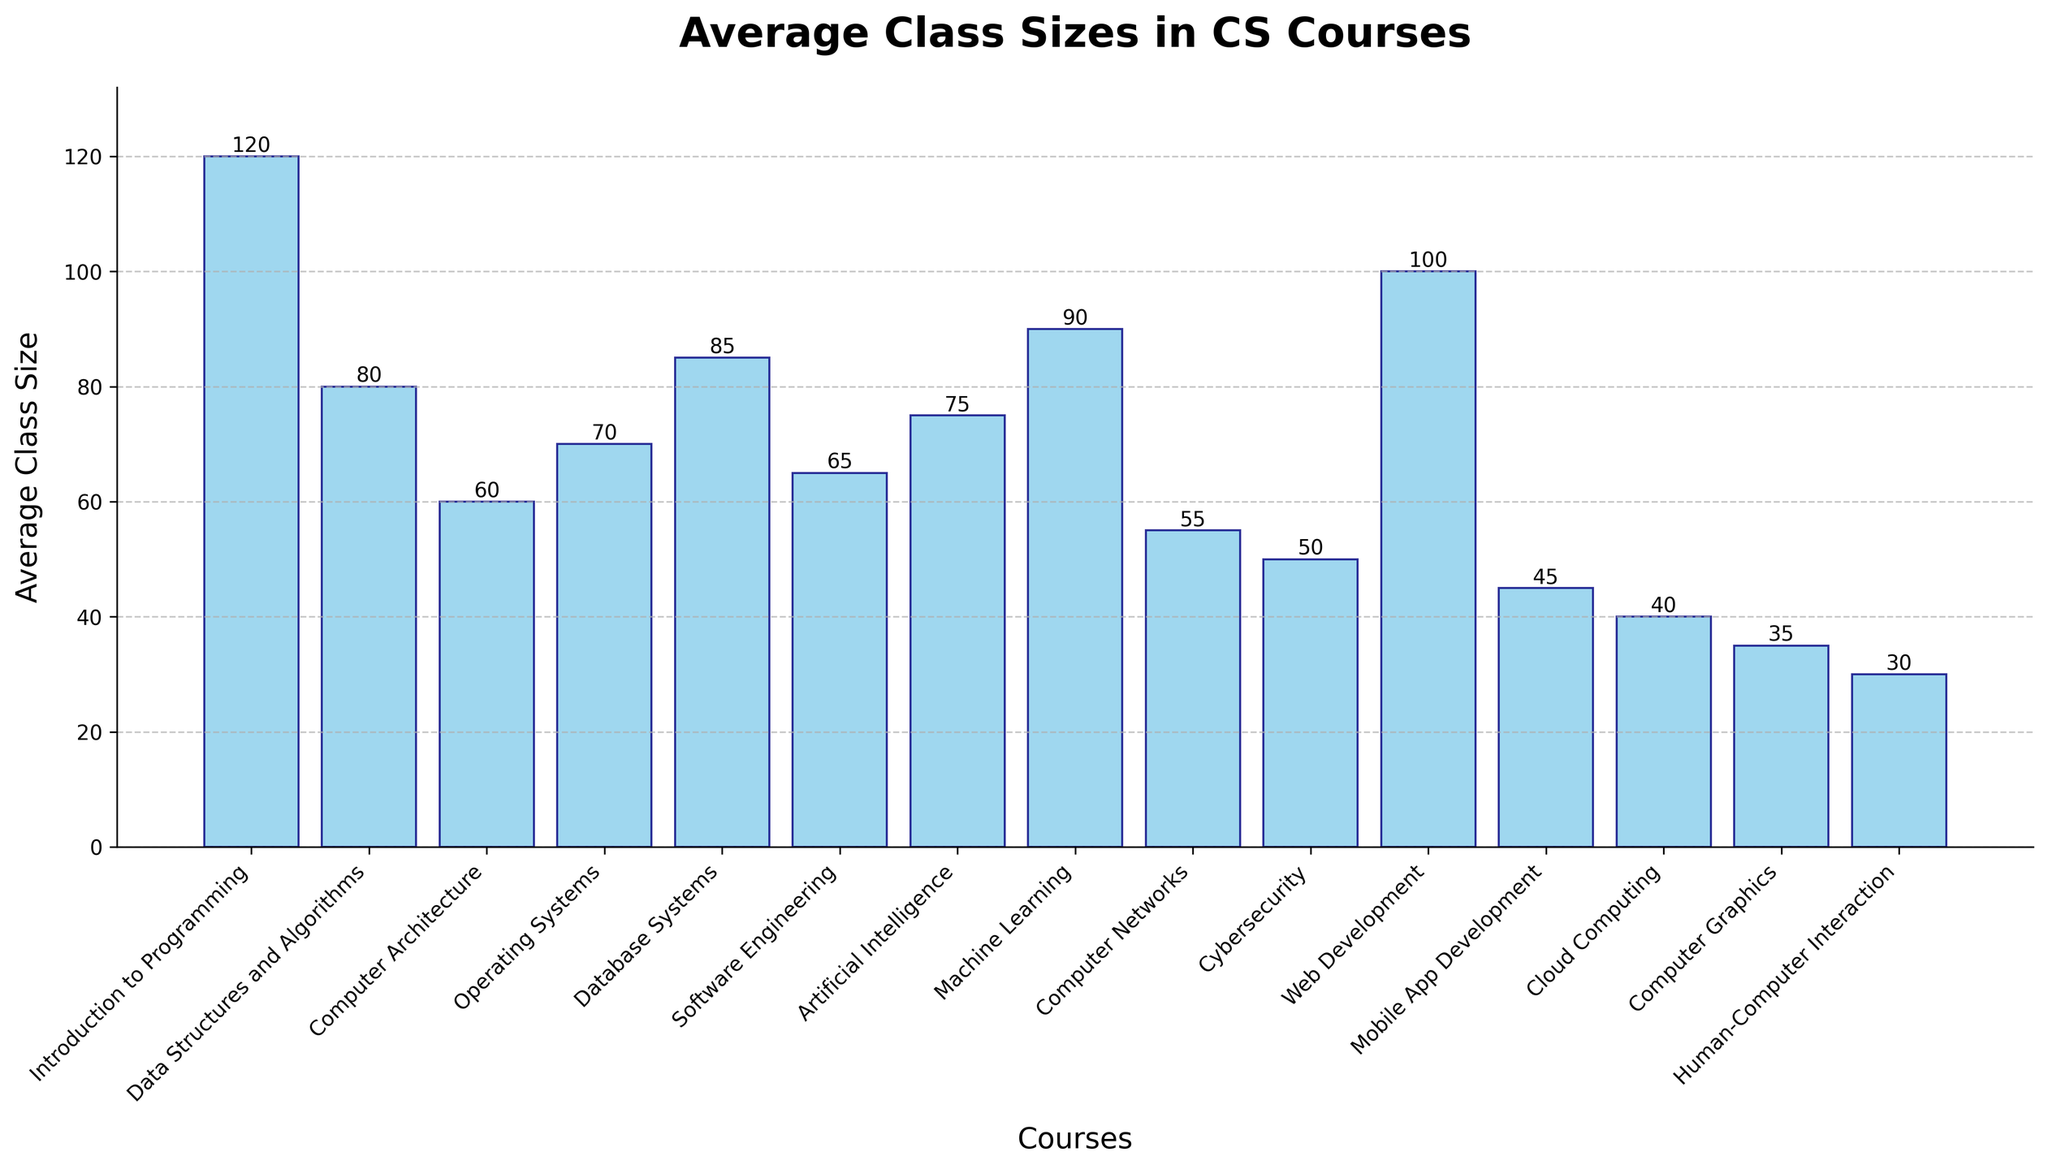Which course has the highest average class size? Look for the bar that reaches the highest point on the y-axis. "Introduction to Programming" has the highest bar.
Answer: Introduction to Programming Which course has the lowest average class size? Look for the bar that is the shortest on the y-axis. "Human-Computer Interaction" has the shortest bar.
Answer: Human-Computer Interaction How much larger is the average class size of "Machine Learning" compared to "Computer Networks"? Observe the heights of the bars for both courses and subtract the smaller from the larger. "Machine Learning" is 90, "Computer Networks" is 55. Subtract 55 from 90.
Answer: 35 What's the range of average class sizes in the figure? Identify the highest and lowest values of class sizes and subtract the smallest from the largest. The highest is 120 (Introduction to Programming) and the lowest is 30 (Human-Computer Interaction). Subtract 30 from 120.
Answer: 90 Which courses have average class sizes greater than 80? Look at the heights of the bars and list those above the 80 mark. The courses are "Introduction to Programming", "Data Structures and Algorithms", "Database Systems", and "Web Development".
Answer: Introduction to Programming, Data Structures and Algorithms, Database Systems, Web Development Are there more courses with average class sizes above 70 or below 50? Count the number of courses with average class sizes above 70 and those below 50. There are 4 above (Introduction to Programming, Data Structures and Algorithms, Database Systems, Machine Learning, Web Development) and 4 below (Mobile App Development, Cloud Computing, Computer Graphics, Human-Computer Interaction).
Answer: Equal What is the total average class size for "Operating Systems", "Database Systems", and "Artificial Intelligence"? Locate the bars for the three courses and add their heights. "Operating Systems": 70, "Database Systems": 85, "Artificial Intelligence": 75, therefore, 70 + 85 + 75.
Answer: 230 Which two courses have the smallest difference in average class sizes? Find the pairs of bars that are closest in height and calculate the difference. "Mobile App Development" and "Cloud Computing" have class sizes of 45 and 40, respectively, giving a difference of 5.
Answer: Mobile App Development, Cloud Computing What is the average class size for all courses combined? Sum all the average class sizes and divide by the number of courses. (120 + 80 + 60 + 70 + 85 + 65 + 75 + 90 + 55 + 50 + 100 + 45 + 40 + 35 + 30) / 15
Answer: 66.7 